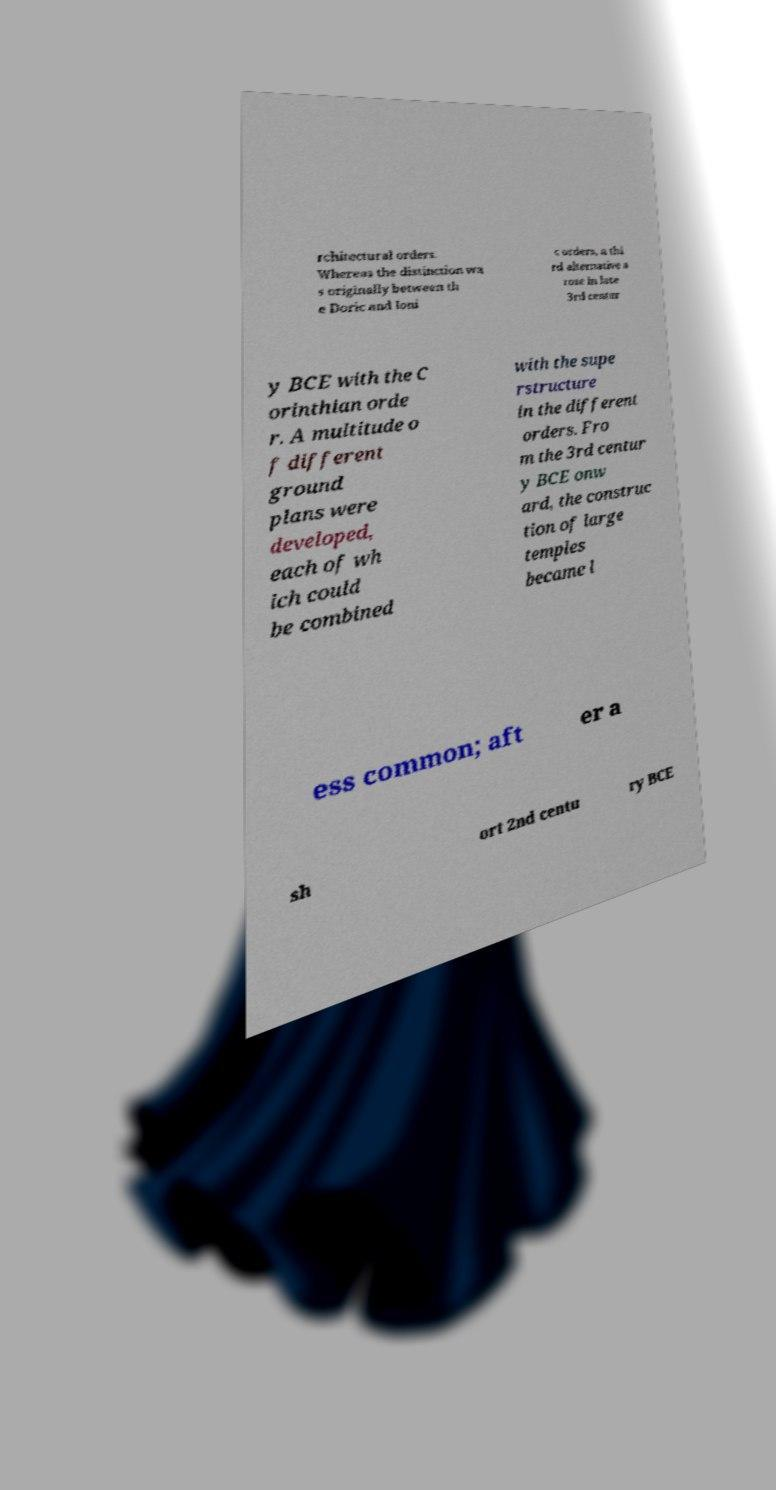Please read and relay the text visible in this image. What does it say? rchitectural orders. Whereas the distinction wa s originally between th e Doric and Ioni c orders, a thi rd alternative a rose in late 3rd centur y BCE with the C orinthian orde r. A multitude o f different ground plans were developed, each of wh ich could be combined with the supe rstructure in the different orders. Fro m the 3rd centur y BCE onw ard, the construc tion of large temples became l ess common; aft er a sh ort 2nd centu ry BCE 